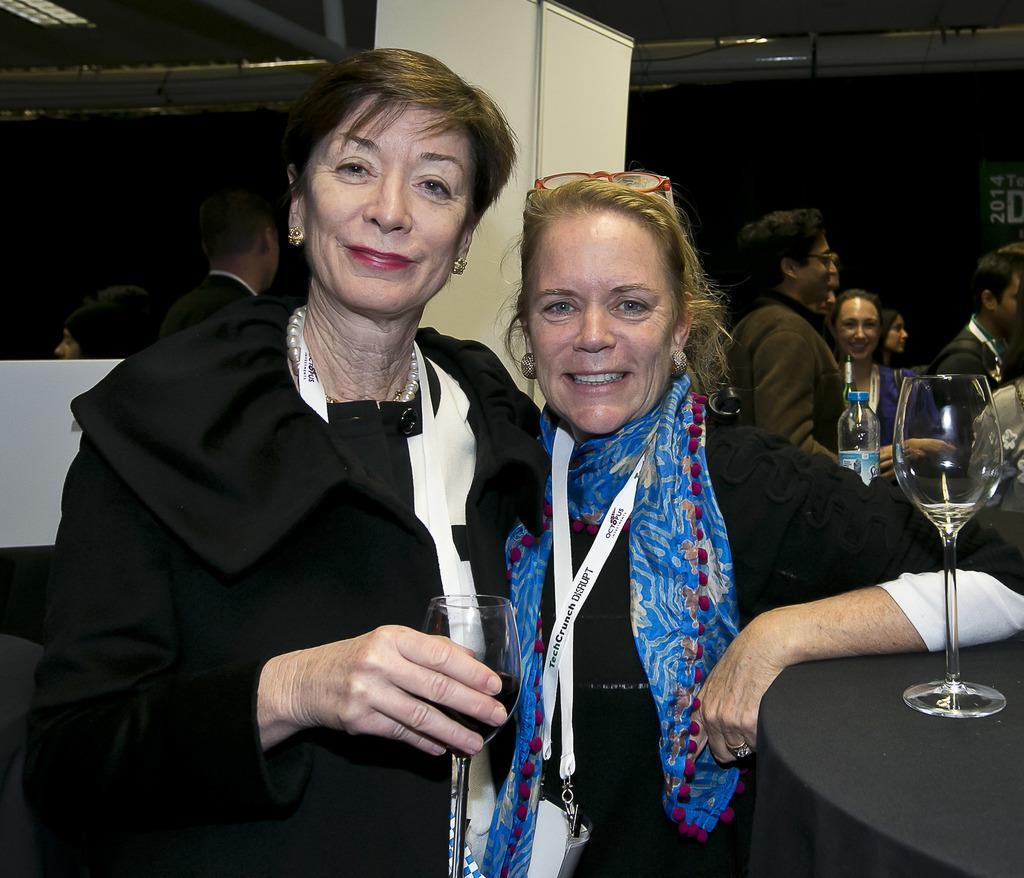How would you summarize this image in a sentence or two? There are two women standing. Woman on the left is holding a glass. Both are wearing tags. Woman on the right is wearing a scarf and a specs on the head. On the right side there is a platform with glass. In the back there are many people. Also there is a bottle. On the ceiling there are pipes. 